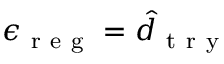<formula> <loc_0><loc_0><loc_500><loc_500>\epsilon _ { r e g } = \hat { d } _ { t r y }</formula> 